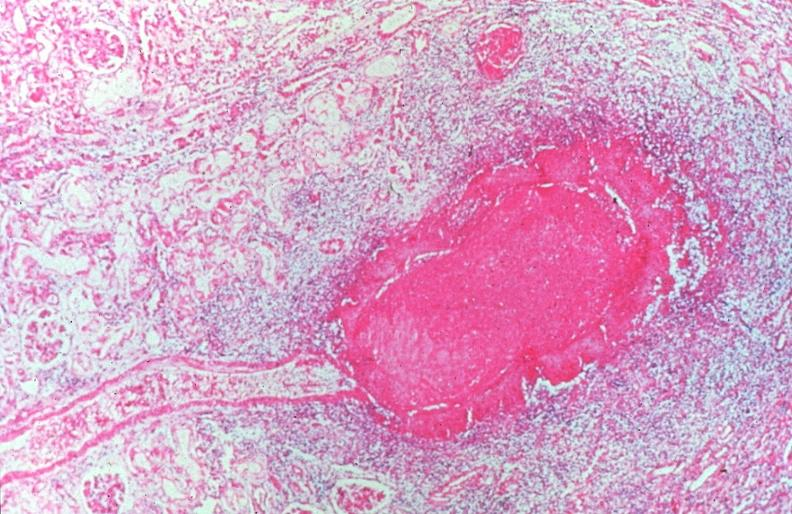s acid present?
Answer the question using a single word or phrase. No 